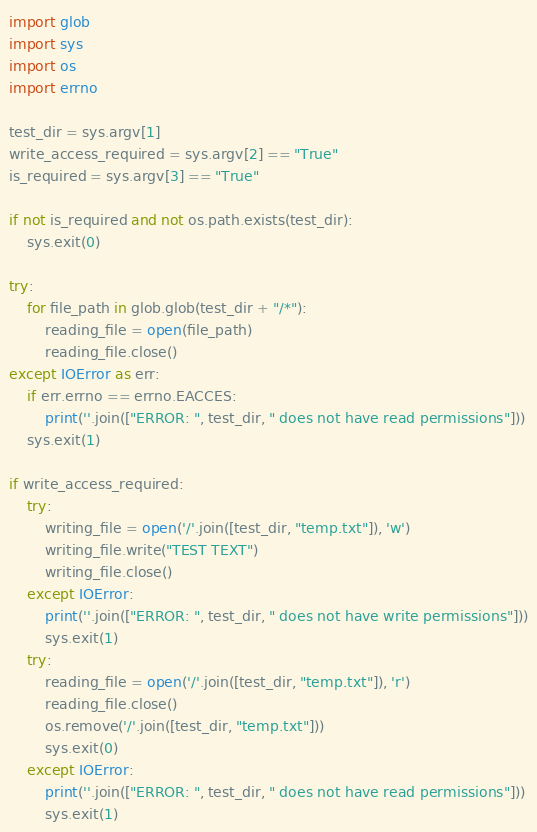<code> <loc_0><loc_0><loc_500><loc_500><_Python_>import glob
import sys
import os
import errno

test_dir = sys.argv[1]
write_access_required = sys.argv[2] == "True"
is_required = sys.argv[3] == "True"

if not is_required and not os.path.exists(test_dir):
    sys.exit(0)

try:
    for file_path in glob.glob(test_dir + "/*"):
        reading_file = open(file_path)
        reading_file.close()
except IOError as err:
    if err.errno == errno.EACCES:
        print(''.join(["ERROR: ", test_dir, " does not have read permissions"]))
    sys.exit(1)

if write_access_required:
    try:
        writing_file = open('/'.join([test_dir, "temp.txt"]), 'w')
        writing_file.write("TEST TEXT")
        writing_file.close()
    except IOError:
        print(''.join(["ERROR: ", test_dir, " does not have write permissions"]))
        sys.exit(1)
    try:
        reading_file = open('/'.join([test_dir, "temp.txt"]), 'r')
        reading_file.close()
        os.remove('/'.join([test_dir, "temp.txt"]))
        sys.exit(0)
    except IOError:
        print(''.join(["ERROR: ", test_dir, " does not have read permissions"]))
        sys.exit(1)
</code> 